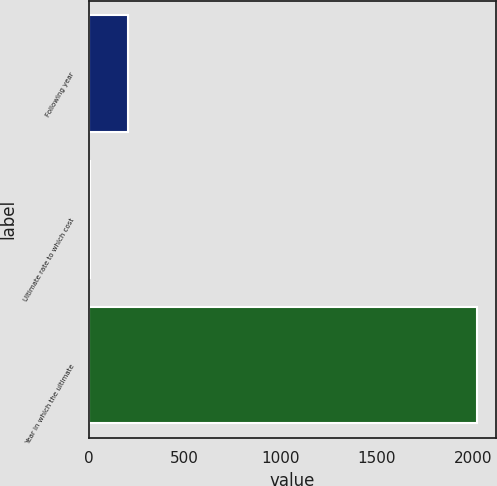Convert chart to OTSL. <chart><loc_0><loc_0><loc_500><loc_500><bar_chart><fcel>Following year<fcel>Ultimate rate to which cost<fcel>Year in which the ultimate<nl><fcel>206.8<fcel>5<fcel>2023<nl></chart> 